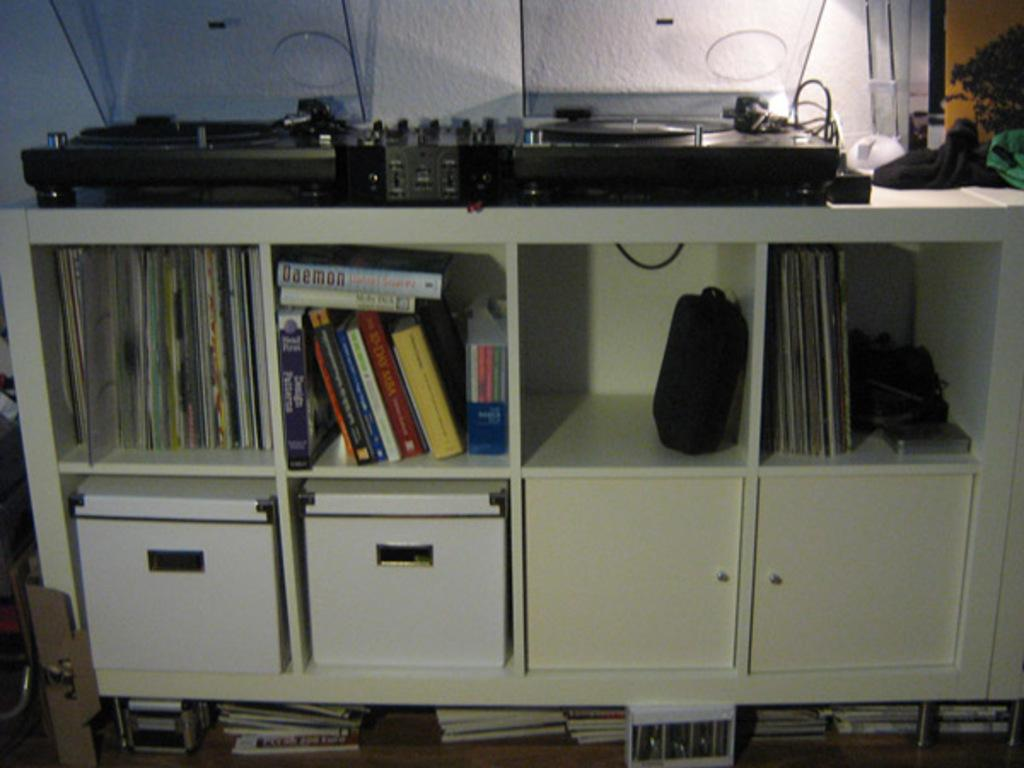What type of items can be seen on shelves in the image? There are books on shelves in the image. What other items can be seen in the image besides books? There are boxes and devices in the image. What is the background of the image? There is a wall visible in the image. Can you describe the other objects present in the image? There are other objects present in the image, but their specific details are not mentioned in the provided facts. What type of furniture is visible in the image? There is no furniture mentioned in the provided facts, so it cannot be determined from the image. 